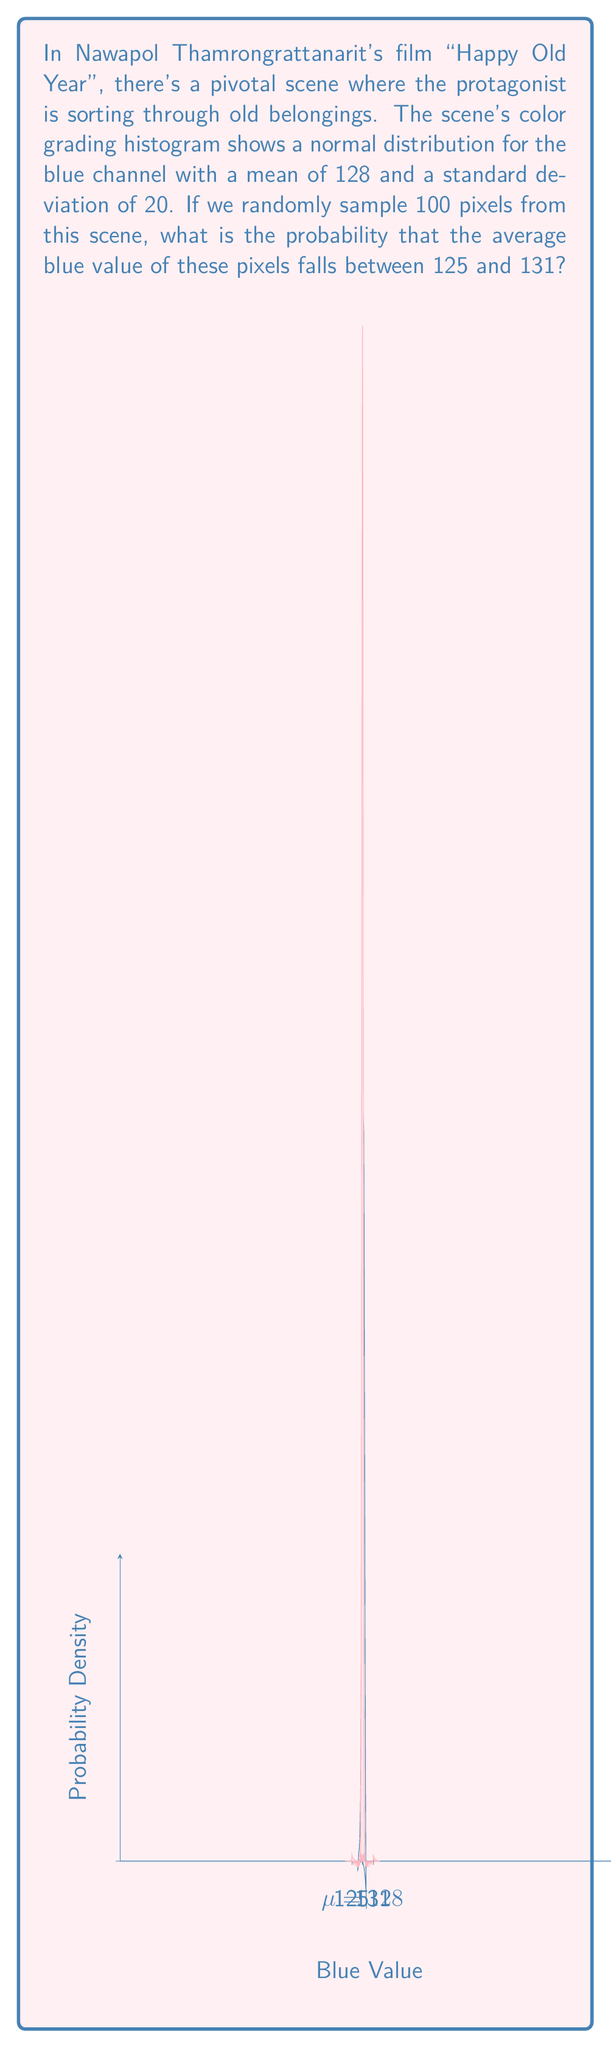Teach me how to tackle this problem. Let's approach this step-by-step:

1) We're dealing with a sampling distribution of the mean. The Central Limit Theorem tells us that for a large sample size (n ≥ 30), the sampling distribution of the mean is approximately normal, regardless of the population distribution.

2) The sampling distribution will have:
   Mean: $\mu_{\bar{X}} = \mu = 128$
   Standard Error: $SE_{\bar{X}} = \frac{\sigma}{\sqrt{n}} = \frac{20}{\sqrt{100}} = 2$

3) We want to find $P(125 < \bar{X} < 131)$

4) We can standardize this to z-scores:
   $z_{125} = \frac{125 - 128}{2} = -1.5$
   $z_{131} = \frac{131 - 128}{2} = 1.5$

5) Now we're looking for $P(-1.5 < Z < 1.5)$

6) Using the standard normal distribution table or a calculator:
   $P(Z < 1.5) = 0.9332$
   $P(Z < -1.5) = 0.0668$

7) Therefore, $P(-1.5 < Z < 1.5) = 0.9332 - 0.0668 = 0.8664$

This means there's a 86.64% chance that the average blue value of 100 randomly sampled pixels will fall between 125 and 131.
Answer: 0.8664 or 86.64% 